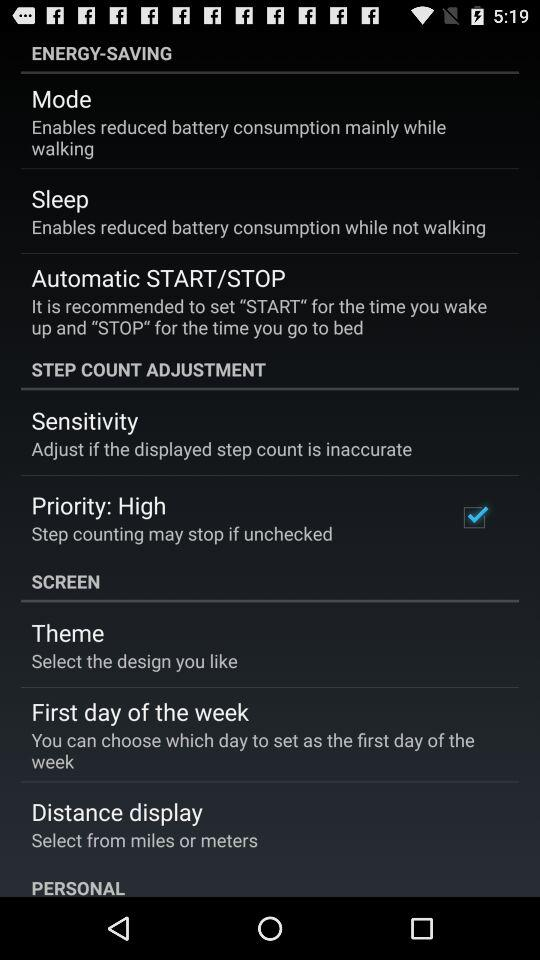What is the status of "Priority: High"? The status is "on". 